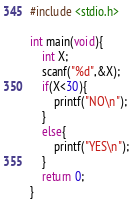<code> <loc_0><loc_0><loc_500><loc_500><_C_>#include <stdio.h>

int main(void){
    int X;
    scanf("%d",&X);
    if(X<30){
        printf("NO\n");
    }
    else{
        printf("YES\n");
    }
    return 0;
}</code> 